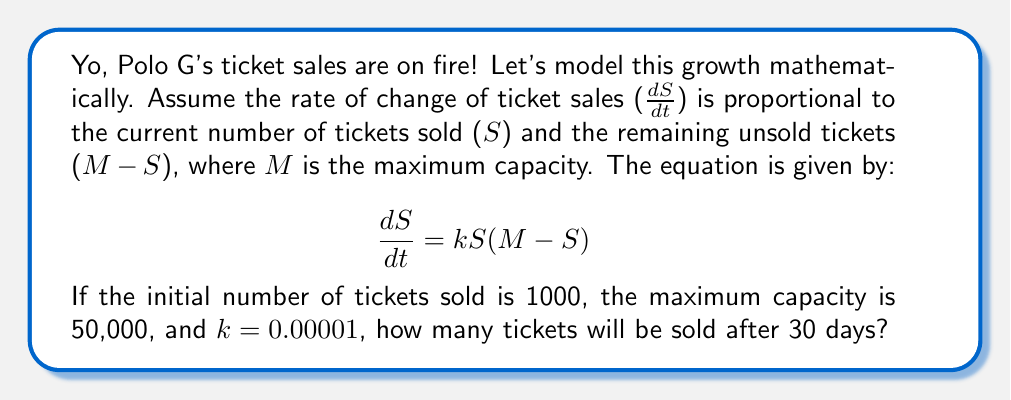Can you solve this math problem? Let's break this down, fam:

1) We're dealing with a logistic growth model, which is perfect for modeling ticket sales that start slow, grow rapidly, and then slow down as we approach capacity.

2) The differential equation we need to solve is:

   $$\frac{dS}{dt} = kS(M-S)$$

3) This equation has the solution:

   $$S(t) = \frac{M}{1 + (\frac{M}{S_0} - 1)e^{-kMt}}$$

   Where $S_0$ is the initial number of tickets sold.

4) Let's plug in our values:
   - $M = 50000$ (maximum capacity)
   - $S_0 = 1000$ (initial tickets sold)
   - $k = 0.00001$
   - $t = 30$ (days)

5) Substituting these into our solution:

   $$S(30) = \frac{50000}{1 + (\frac{50000}{1000} - 1)e^{-0.00001 * 50000 * 30}}$$

6) Let's simplify step by step:
   
   $$S(30) = \frac{50000}{1 + 49e^{-15}}$$
   
   $$S(30) = \frac{50000}{1 + 49 * (2.0611 * 10^{-7})}$$
   
   $$S(30) = \frac{50000}{1.0000101}$$
   
   $$S(30) = 49999.49$$

7) Since we can't sell partial tickets, we round down to the nearest whole number.
Answer: After 30 days, approximately 49,999 tickets will be sold. 